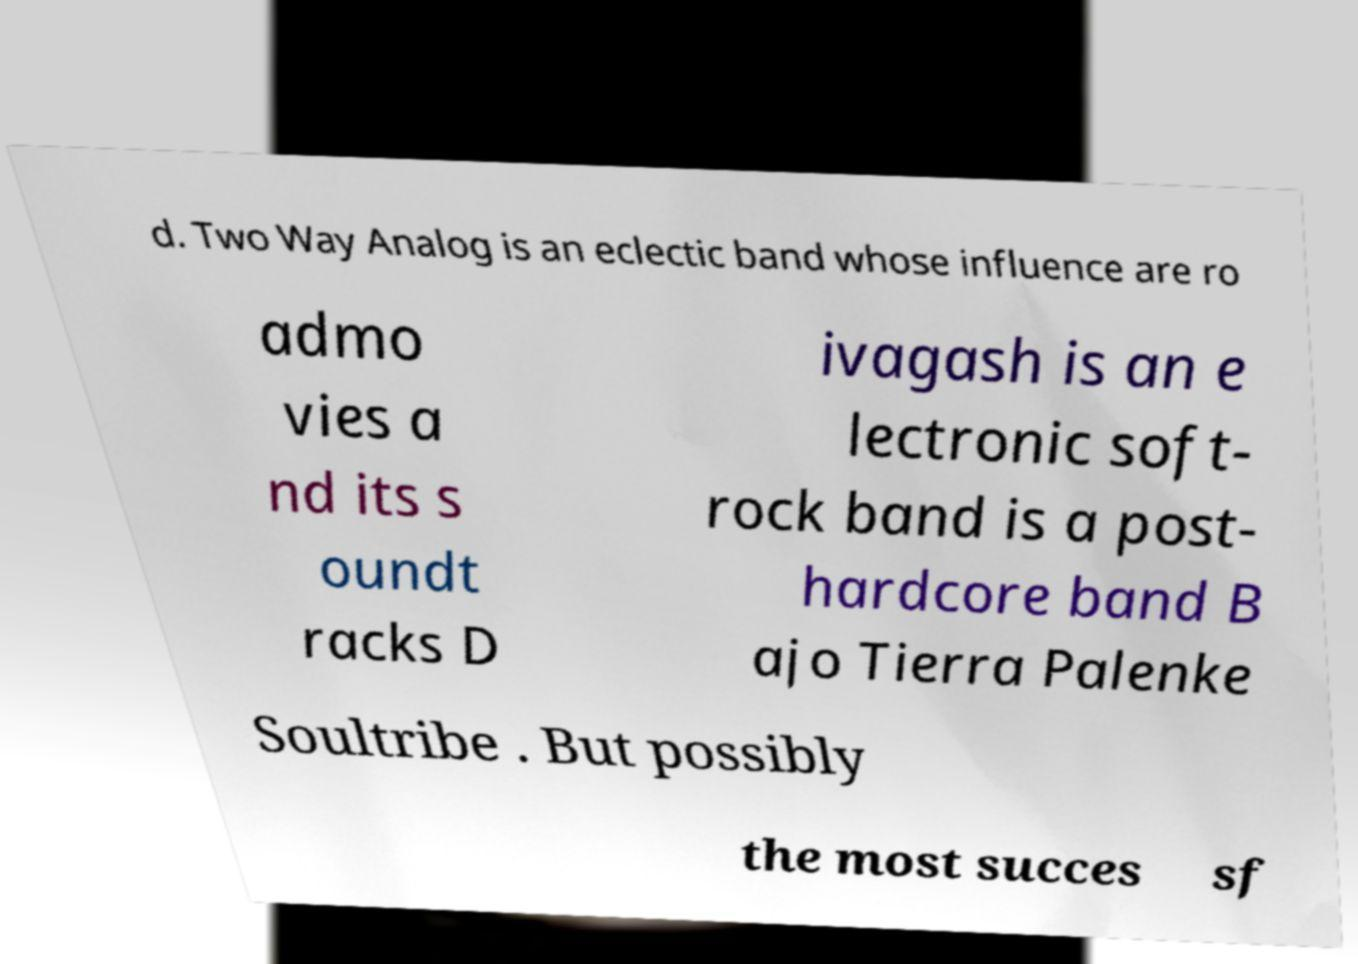Please identify and transcribe the text found in this image. d. Two Way Analog is an eclectic band whose influence are ro admo vies a nd its s oundt racks D ivagash is an e lectronic soft- rock band is a post- hardcore band B ajo Tierra Palenke Soultribe . But possibly the most succes sf 